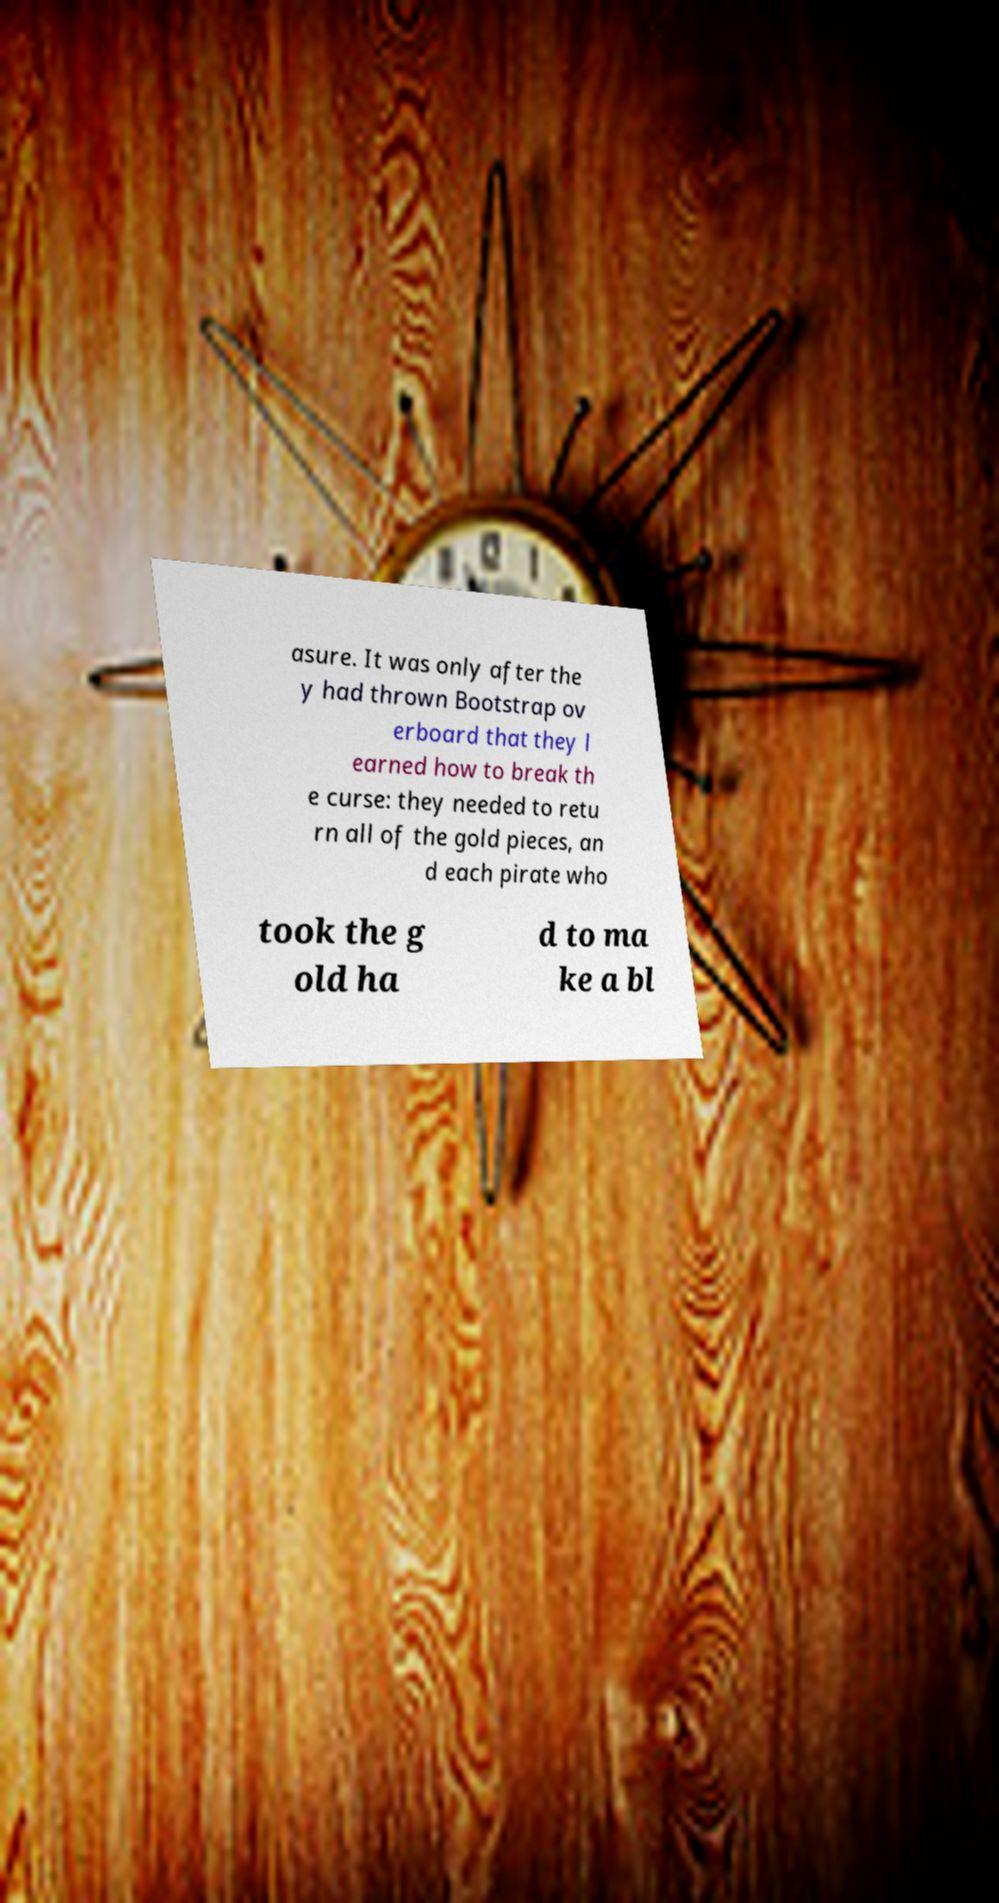What messages or text are displayed in this image? I need them in a readable, typed format. asure. It was only after the y had thrown Bootstrap ov erboard that they l earned how to break th e curse: they needed to retu rn all of the gold pieces, an d each pirate who took the g old ha d to ma ke a bl 